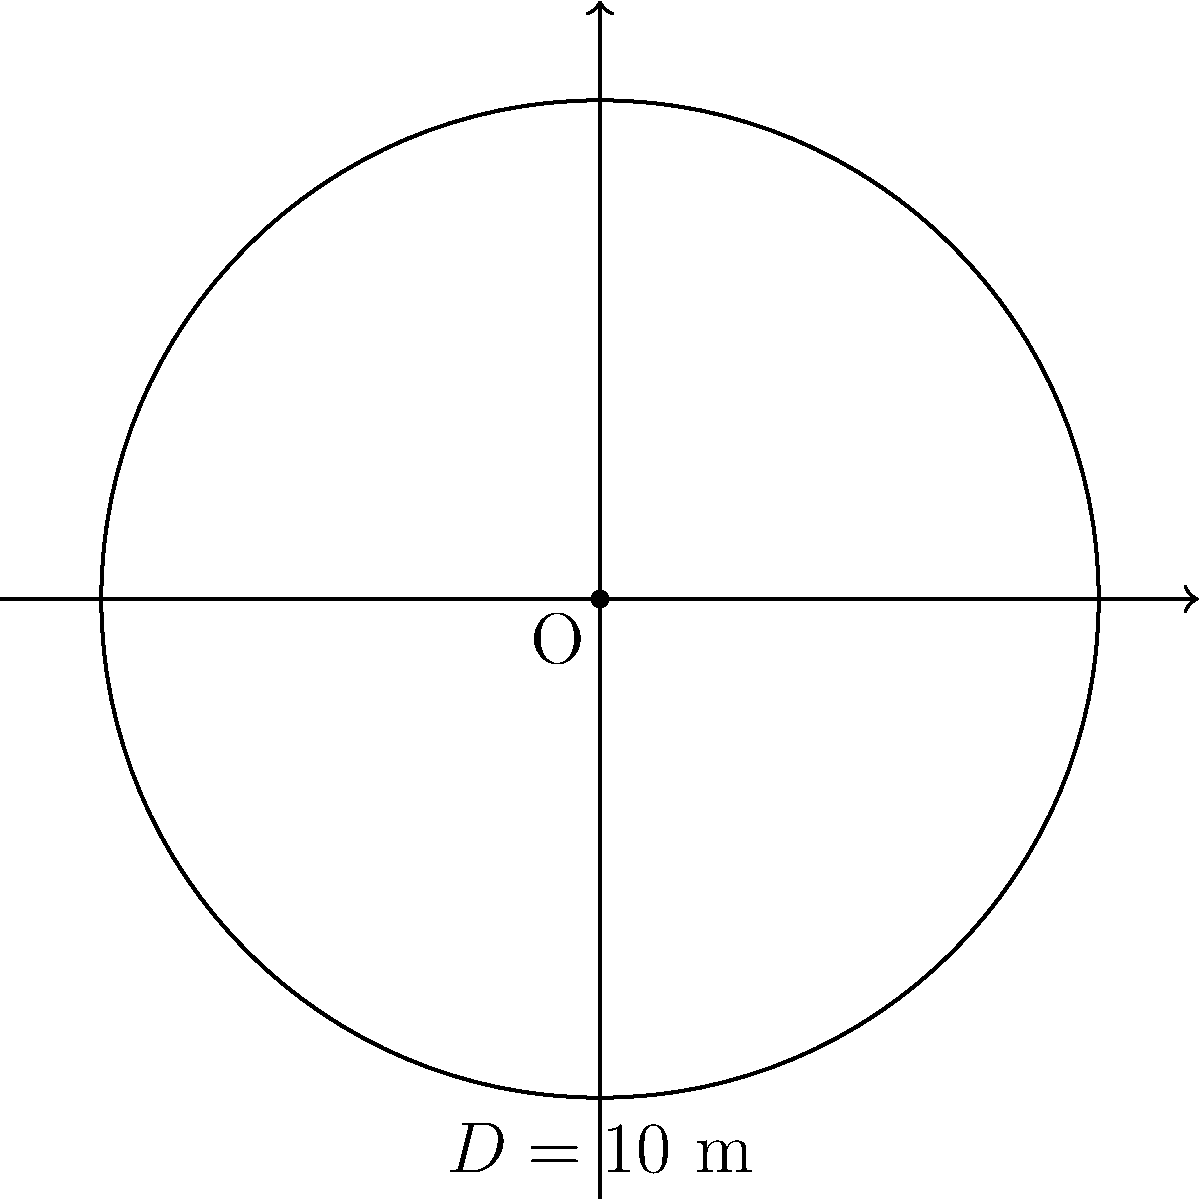As a professional hiker, you need to set up a circular campsite in a clearing. The clearing has a diameter of 10 meters. Calculate the area of the circular clearing to ensure you have enough space for your equipment. Round your answer to the nearest square meter. To calculate the area of a circular clearing, we'll use the formula for the area of a circle: $A = \pi r^2$, where $A$ is the area and $r$ is the radius.

Step 1: Determine the radius
The diameter ($D$) is given as 10 meters. The radius ($r$) is half of the diameter.
$r = \frac{D}{2} = \frac{10}{2} = 5$ meters

Step 2: Apply the area formula
$A = \pi r^2$
$A = \pi \cdot (5\text{ m})^2$
$A = \pi \cdot 25\text{ m}^2$

Step 3: Calculate and round to the nearest square meter
$A \approx 78.54\text{ m}^2$
Rounding to the nearest square meter: $79\text{ m}^2$

Therefore, the area of the circular clearing is approximately 79 square meters.
Answer: $79\text{ m}^2$ 